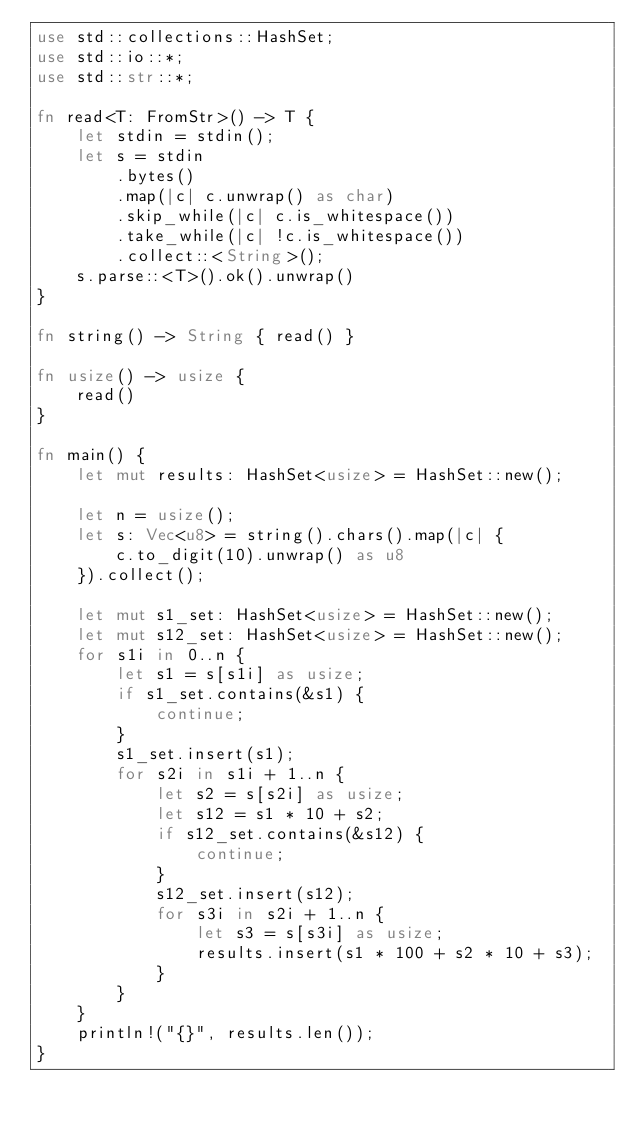<code> <loc_0><loc_0><loc_500><loc_500><_Rust_>use std::collections::HashSet;
use std::io::*;
use std::str::*;

fn read<T: FromStr>() -> T {
    let stdin = stdin();
    let s = stdin
        .bytes()
        .map(|c| c.unwrap() as char)
        .skip_while(|c| c.is_whitespace())
        .take_while(|c| !c.is_whitespace())
        .collect::<String>();
    s.parse::<T>().ok().unwrap()
}

fn string() -> String { read() }

fn usize() -> usize {
    read()
}

fn main() {
    let mut results: HashSet<usize> = HashSet::new();

    let n = usize();
    let s: Vec<u8> = string().chars().map(|c| {
        c.to_digit(10).unwrap() as u8
    }).collect();

    let mut s1_set: HashSet<usize> = HashSet::new();
    let mut s12_set: HashSet<usize> = HashSet::new();
    for s1i in 0..n {
        let s1 = s[s1i] as usize;
        if s1_set.contains(&s1) {
            continue;
        }
        s1_set.insert(s1);
        for s2i in s1i + 1..n {
            let s2 = s[s2i] as usize;
            let s12 = s1 * 10 + s2;
            if s12_set.contains(&s12) {
                continue;
            }
            s12_set.insert(s12);
            for s3i in s2i + 1..n {
                let s3 = s[s3i] as usize;
                results.insert(s1 * 100 + s2 * 10 + s3);
            }
        }
    }
    println!("{}", results.len());
}
</code> 